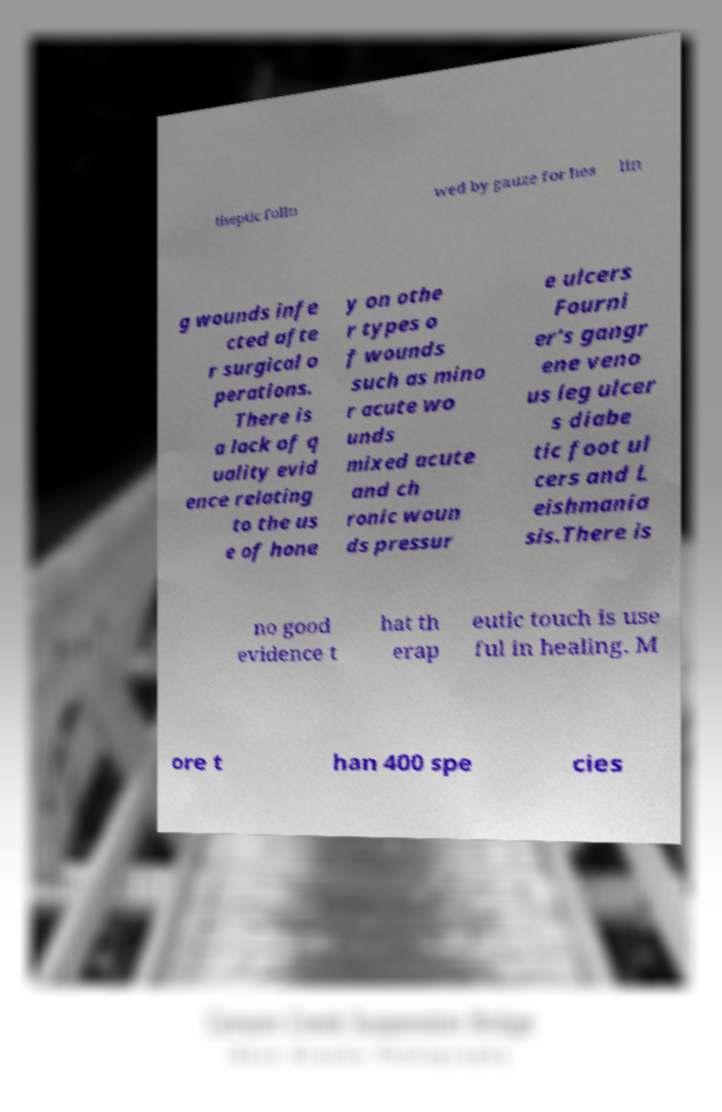There's text embedded in this image that I need extracted. Can you transcribe it verbatim? tiseptic follo wed by gauze for hea lin g wounds infe cted afte r surgical o perations. There is a lack of q uality evid ence relating to the us e of hone y on othe r types o f wounds such as mino r acute wo unds mixed acute and ch ronic woun ds pressur e ulcers Fourni er's gangr ene veno us leg ulcer s diabe tic foot ul cers and L eishmania sis.There is no good evidence t hat th erap eutic touch is use ful in healing. M ore t han 400 spe cies 